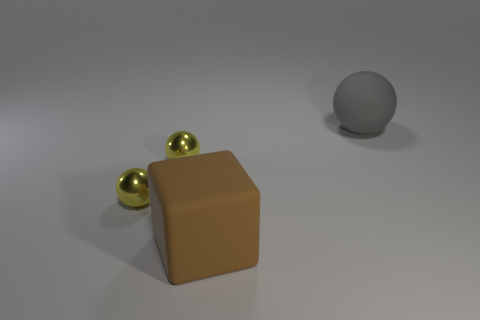Subtract all small shiny balls. How many balls are left? 1 Add 3 blue metallic things. How many objects exist? 7 Subtract all blocks. How many objects are left? 3 Add 2 large brown matte objects. How many large brown matte objects are left? 3 Add 1 big things. How many big things exist? 3 Subtract 0 brown spheres. How many objects are left? 4 Subtract all brown matte cubes. Subtract all big brown objects. How many objects are left? 2 